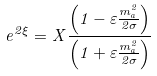Convert formula to latex. <formula><loc_0><loc_0><loc_500><loc_500>e ^ { 2 \xi } = X \frac { \left ( 1 - \varepsilon \frac { m _ { a } ^ { 2 } } { 2 \sigma } \right ) } { \left ( 1 + \varepsilon \frac { m _ { a } ^ { 2 } } { 2 \sigma } \right ) }</formula> 